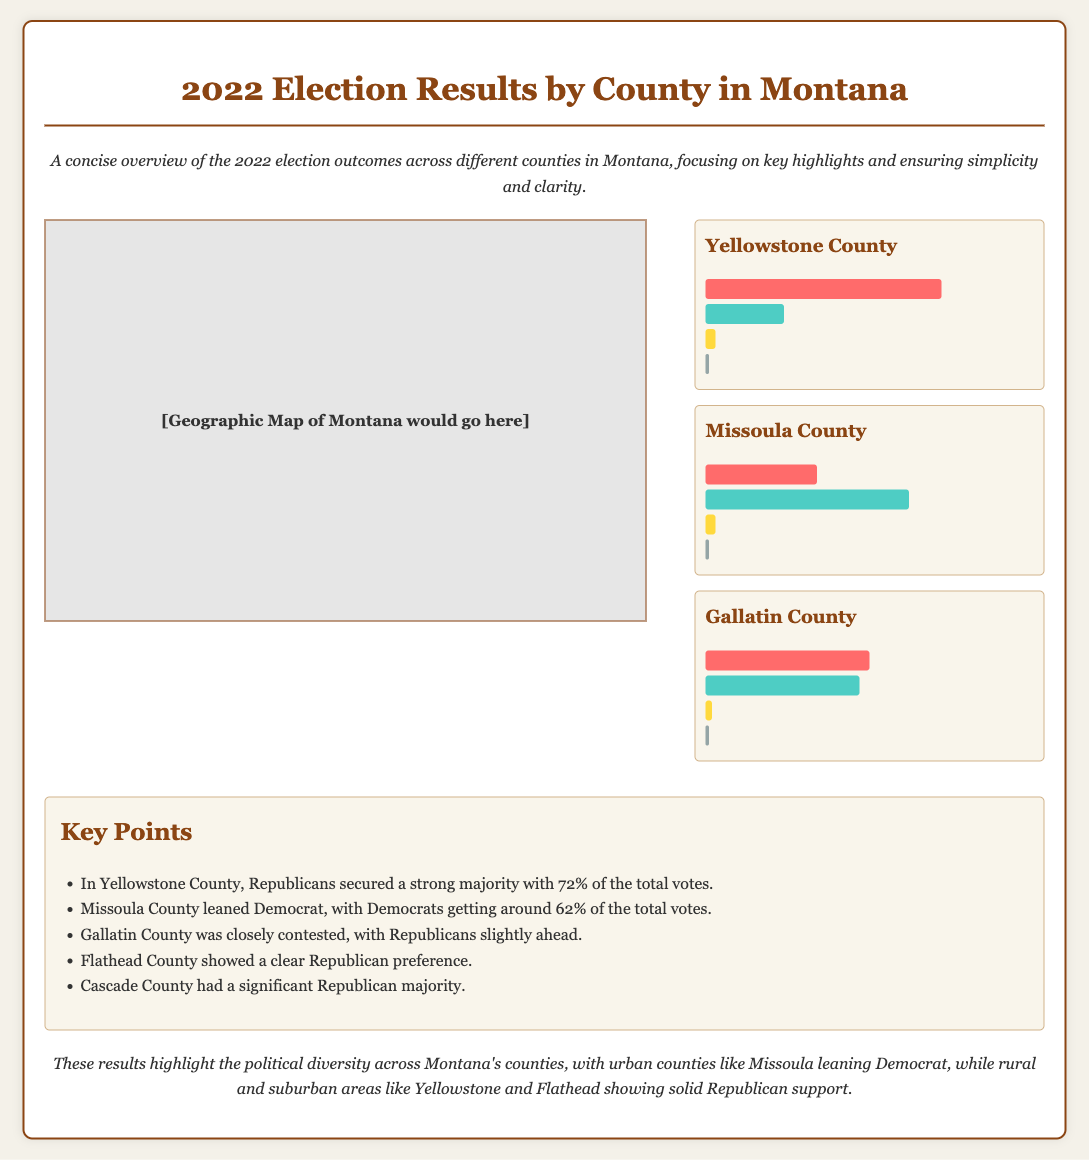What percentage of votes did Republicans receive in Yellowstone County? The document states that Republicans secured 72% of the total votes in Yellowstone County.
Answer: 72% Which county had the highest percentage of Democrat votes? According to the document, Missoula County had the highest percentage of Democrat votes at 62%.
Answer: Missoula County What is the percentage of votes for Libertarians in Gallatin County? The document mentions that Libertarians received 2% of the votes in Gallatin County.
Answer: 2% Which county shows a clear Republican preference? The key points highlight that Flathead County showed a clear Republican preference.
Answer: Flathead County What was the total percentage of votes for Democrats in Missoula County? The document states that Democrats received 62% of the total votes in Missoula County.
Answer: 62% Which county had a closely contested election? The document describes Gallatin County as being closely contested.
Answer: Gallatin County What color represents Republican votes in the infographic? The document uses the color red to represent Republican votes.
Answer: Red What is the color for votes categorized as 'others'? According to the document, the color gray is used for votes categorized as 'others'.
Answer: Gray How many counties are listed in the results section of the infographic? The results section includes three counties: Yellowstone, Missoula, and Gallatin.
Answer: Three 